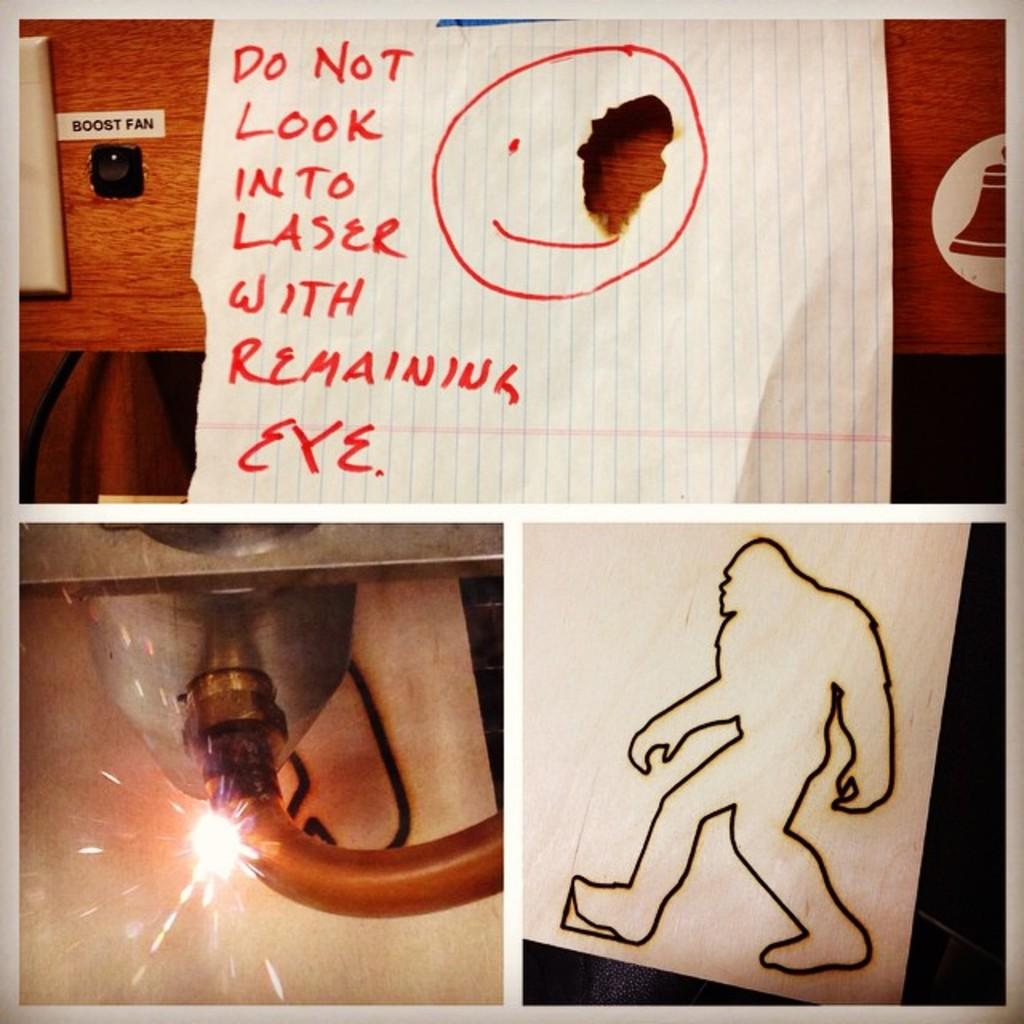What type of artwork is depicted in the image? The image is a collage. What types of papers are included in the collage? There are papers with drawings and papers with writing in the collage. What material is used for the wooden object in the collage? The wooden object in the collage is made of wood. What visual effect is present in the collage? There are sparks visible in the collage. Can you describe any other unspecified objects in the collage? There are other unspecified objects in the collage, but their details are not mentioned in the provided facts. How does the collage express love? The collage does not express love, as there is no mention of love or any related symbols or themes in the provided facts. --- Facts: 1. There is a person sitting on a chair in the image. 2. The person is holding a book. 3. The book has a blue cover. 4. The chair is made of wood. 5. There is a table next to the chair. 6. The table has a lamp on it. Absurd Topics: dance, ocean, bird Conversation: What is the person in the image doing? The person in the image is sitting on a chair. What is the person holding in the image? The person is holding a book. What color is the book's cover? The book has a blue cover. What material is the chair made of? The chair is made of wood. What object is on the table next to the chair? There is a lamp on the table. Reasoning: Let's think step by step in order to produce the conversation. We start by identifying the main subject in the image, which is the person sitting on a chair. Then, we expand the conversation to include the book the person is holding, its blue cover, the wooden chair, and the table with a lamp on it. Each question is designed to elicit a specific detail about the image that is known from the provided facts. Absurd Question/Answer: Can you see any dancing taking place in the image? There is no dancing taking place in the image, as the person is sitting and reading a book. --- Facts: 1. There is a person standing on a bridge in the image. 2. The person is holding a camera. 3. The bridge is made of metal. 4. There is a river flowing under the bridge. 5. The sky is visible in the background. Absurd Topics: snow, parrot, bicycle Conversation: What is the person in the image doing? The person in the image is standing on a bridge. What is the person holding in the image? The person is holding a camera. What material is the bridge made of? The bridge is made of metal. 